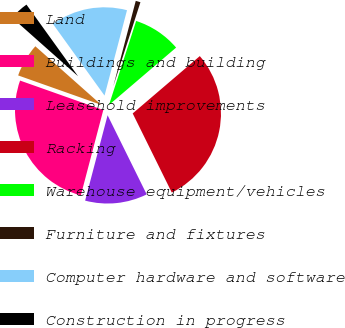<chart> <loc_0><loc_0><loc_500><loc_500><pie_chart><fcel>Land<fcel>Buildings and building<fcel>Leasehold improvements<fcel>Racking<fcel>Warehouse equipment/vehicles<fcel>Furniture and fixtures<fcel>Computer hardware and software<fcel>Construction in progress<nl><fcel>6.14%<fcel>26.32%<fcel>11.4%<fcel>28.95%<fcel>8.77%<fcel>0.88%<fcel>14.03%<fcel>3.51%<nl></chart> 